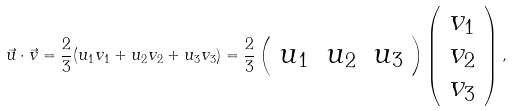<formula> <loc_0><loc_0><loc_500><loc_500>\vec { u } \cdot \vec { v } = \frac { 2 } { 3 } ( u _ { 1 } v _ { 1 } + u _ { 2 } v _ { 2 } + u _ { 3 } v _ { 3 } ) = \frac { 2 } { 3 } \left ( \begin{array} { l l l } u _ { 1 } & u _ { 2 } & u _ { 3 } \end{array} \right ) \left ( \begin{array} { r } v _ { 1 } \\ v _ { 2 } \\ v _ { 3 } \end{array} \right ) ,</formula> 